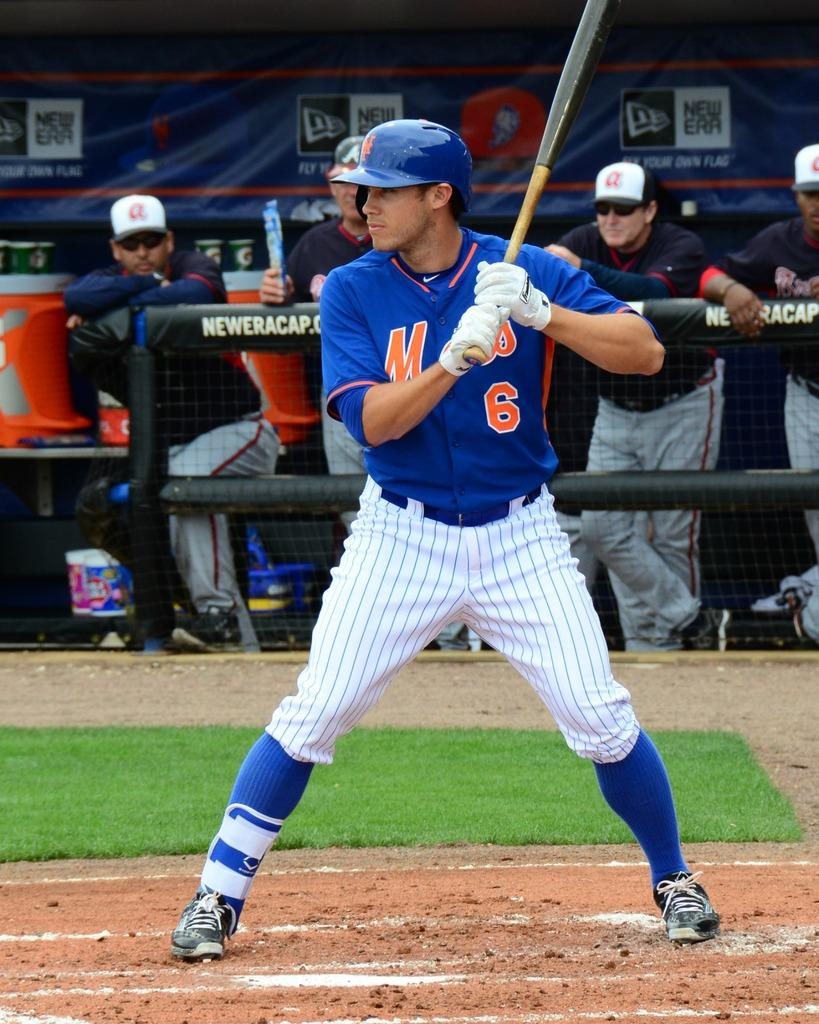<image>
Present a compact description of the photo's key features. A baseball player wears a blue Mets uniform. 